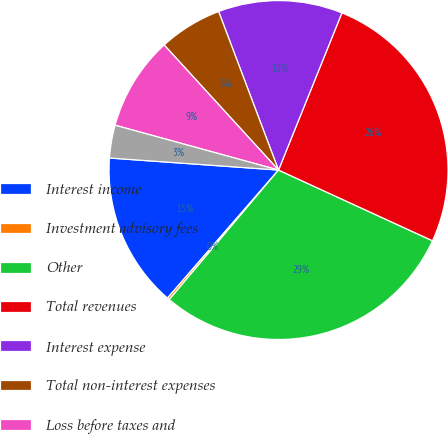<chart> <loc_0><loc_0><loc_500><loc_500><pie_chart><fcel>Interest income<fcel>Investment advisory fees<fcel>Other<fcel>Total revenues<fcel>Interest expense<fcel>Total non-interest expenses<fcel>Loss before taxes and<fcel>Pre-tax loss excluding<nl><fcel>14.76%<fcel>0.22%<fcel>29.3%<fcel>25.75%<fcel>11.85%<fcel>6.04%<fcel>8.95%<fcel>3.13%<nl></chart> 